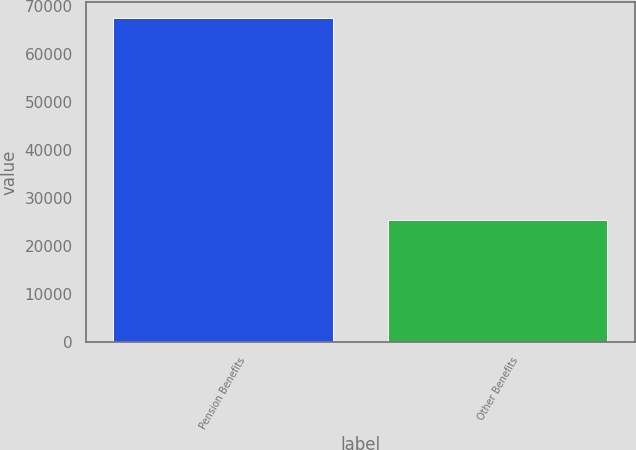Convert chart. <chart><loc_0><loc_0><loc_500><loc_500><bar_chart><fcel>Pension Benefits<fcel>Other Benefits<nl><fcel>67617<fcel>25491<nl></chart> 